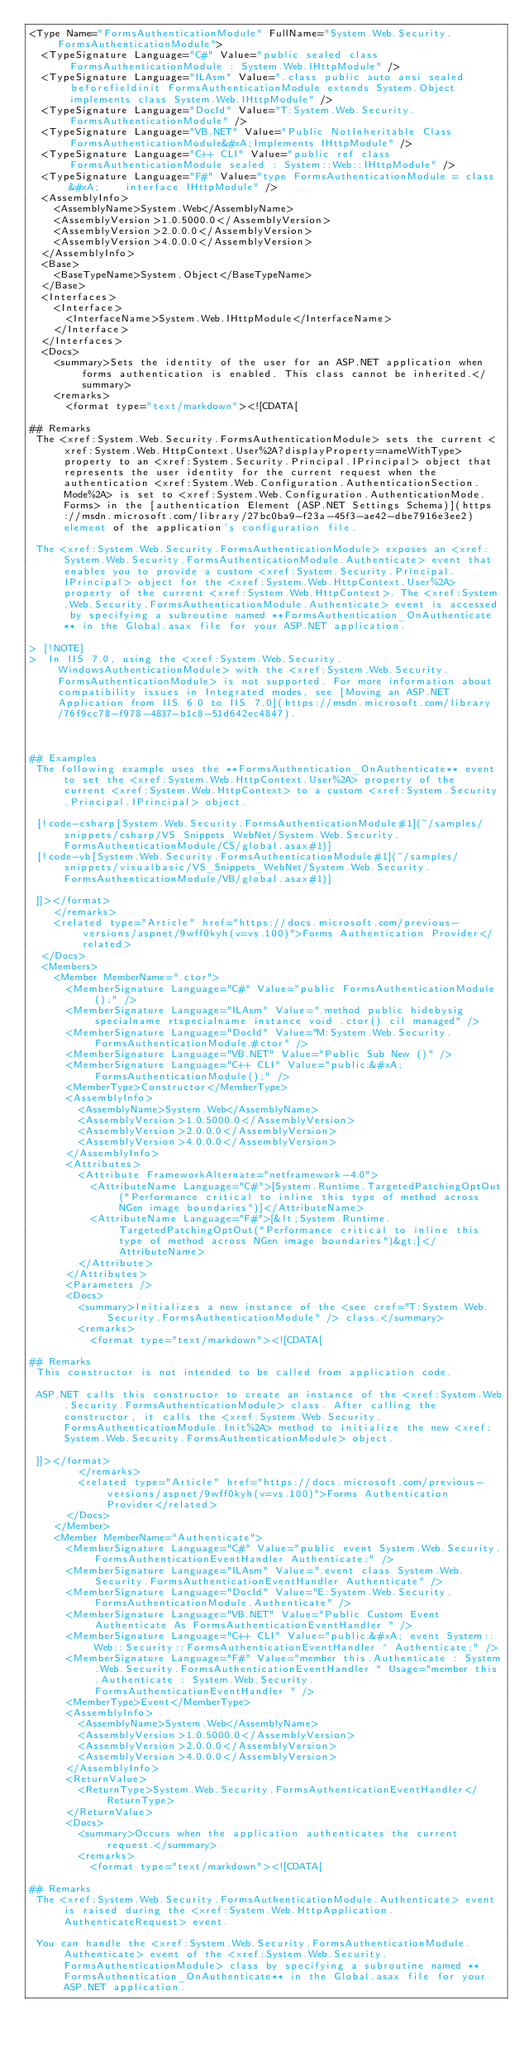<code> <loc_0><loc_0><loc_500><loc_500><_XML_><Type Name="FormsAuthenticationModule" FullName="System.Web.Security.FormsAuthenticationModule">
  <TypeSignature Language="C#" Value="public sealed class FormsAuthenticationModule : System.Web.IHttpModule" />
  <TypeSignature Language="ILAsm" Value=".class public auto ansi sealed beforefieldinit FormsAuthenticationModule extends System.Object implements class System.Web.IHttpModule" />
  <TypeSignature Language="DocId" Value="T:System.Web.Security.FormsAuthenticationModule" />
  <TypeSignature Language="VB.NET" Value="Public NotInheritable Class FormsAuthenticationModule&#xA;Implements IHttpModule" />
  <TypeSignature Language="C++ CLI" Value="public ref class FormsAuthenticationModule sealed : System::Web::IHttpModule" />
  <TypeSignature Language="F#" Value="type FormsAuthenticationModule = class&#xA;    interface IHttpModule" />
  <AssemblyInfo>
    <AssemblyName>System.Web</AssemblyName>
    <AssemblyVersion>1.0.5000.0</AssemblyVersion>
    <AssemblyVersion>2.0.0.0</AssemblyVersion>
    <AssemblyVersion>4.0.0.0</AssemblyVersion>
  </AssemblyInfo>
  <Base>
    <BaseTypeName>System.Object</BaseTypeName>
  </Base>
  <Interfaces>
    <Interface>
      <InterfaceName>System.Web.IHttpModule</InterfaceName>
    </Interface>
  </Interfaces>
  <Docs>
    <summary>Sets the identity of the user for an ASP.NET application when forms authentication is enabled. This class cannot be inherited.</summary>
    <remarks>
      <format type="text/markdown"><![CDATA[  
  
## Remarks  
 The <xref:System.Web.Security.FormsAuthenticationModule> sets the current <xref:System.Web.HttpContext.User%2A?displayProperty=nameWithType> property to an <xref:System.Security.Principal.IPrincipal> object that represents the user identity for the current request when the authentication <xref:System.Web.Configuration.AuthenticationSection.Mode%2A> is set to <xref:System.Web.Configuration.AuthenticationMode.Forms> in the [authentication Element (ASP.NET Settings Schema)](https://msdn.microsoft.com/library/27bc0ba9-f23a-45f3-ae42-dbe7916e3ee2) element of the application's configuration file.  
  
 The <xref:System.Web.Security.FormsAuthenticationModule> exposes an <xref:System.Web.Security.FormsAuthenticationModule.Authenticate> event that enables you to provide a custom <xref:System.Security.Principal.IPrincipal> object for the <xref:System.Web.HttpContext.User%2A> property of the current <xref:System.Web.HttpContext>. The <xref:System.Web.Security.FormsAuthenticationModule.Authenticate> event is accessed by specifying a subroutine named **FormsAuthentication_OnAuthenticate** in the Global.asax file for your ASP.NET application.  
  
> [!NOTE]
>  In IIS 7.0, using the <xref:System.Web.Security.WindowsAuthenticationModule> with the <xref:System.Web.Security.FormsAuthenticationModule> is not supported. For more information about compatibility issues in Integrated modes, see [Moving an ASP.NET Application from IIS 6.0 to IIS 7.0](https://msdn.microsoft.com/library/76f9cc78-f978-4837-b1c8-51d642ec4847).  
  
   
  
## Examples  
 The following example uses the **FormsAuthentication_OnAuthenticate** event to set the <xref:System.Web.HttpContext.User%2A> property of the current <xref:System.Web.HttpContext> to a custom <xref:System.Security.Principal.IPrincipal> object.  
  
 [!code-csharp[System.Web.Security.FormsAuthenticationModule#1](~/samples/snippets/csharp/VS_Snippets_WebNet/System.Web.Security.FormsAuthenticationModule/CS/global.asax#1)]
 [!code-vb[System.Web.Security.FormsAuthenticationModule#1](~/samples/snippets/visualbasic/VS_Snippets_WebNet/System.Web.Security.FormsAuthenticationModule/VB/global.asax#1)]  
  
 ]]></format>
    </remarks>
    <related type="Article" href="https://docs.microsoft.com/previous-versions/aspnet/9wff0kyh(v=vs.100)">Forms Authentication Provider</related>
  </Docs>
  <Members>
    <Member MemberName=".ctor">
      <MemberSignature Language="C#" Value="public FormsAuthenticationModule ();" />
      <MemberSignature Language="ILAsm" Value=".method public hidebysig specialname rtspecialname instance void .ctor() cil managed" />
      <MemberSignature Language="DocId" Value="M:System.Web.Security.FormsAuthenticationModule.#ctor" />
      <MemberSignature Language="VB.NET" Value="Public Sub New ()" />
      <MemberSignature Language="C++ CLI" Value="public:&#xA; FormsAuthenticationModule();" />
      <MemberType>Constructor</MemberType>
      <AssemblyInfo>
        <AssemblyName>System.Web</AssemblyName>
        <AssemblyVersion>1.0.5000.0</AssemblyVersion>
        <AssemblyVersion>2.0.0.0</AssemblyVersion>
        <AssemblyVersion>4.0.0.0</AssemblyVersion>
      </AssemblyInfo>
      <Attributes>
        <Attribute FrameworkAlternate="netframework-4.0">
          <AttributeName Language="C#">[System.Runtime.TargetedPatchingOptOut("Performance critical to inline this type of method across NGen image boundaries")]</AttributeName>
          <AttributeName Language="F#">[&lt;System.Runtime.TargetedPatchingOptOut("Performance critical to inline this type of method across NGen image boundaries")&gt;]</AttributeName>
        </Attribute>
      </Attributes>
      <Parameters />
      <Docs>
        <summary>Initializes a new instance of the <see cref="T:System.Web.Security.FormsAuthenticationModule" /> class.</summary>
        <remarks>
          <format type="text/markdown"><![CDATA[  
  
## Remarks  
 This constructor is not intended to be called from application code.  
  
 ASP.NET calls this constructor to create an instance of the <xref:System.Web.Security.FormsAuthenticationModule> class. After calling the constructor, it calls the <xref:System.Web.Security.FormsAuthenticationModule.Init%2A> method to initialize the new <xref:System.Web.Security.FormsAuthenticationModule> object.  
  
 ]]></format>
        </remarks>
        <related type="Article" href="https://docs.microsoft.com/previous-versions/aspnet/9wff0kyh(v=vs.100)">Forms Authentication Provider</related>
      </Docs>
    </Member>
    <Member MemberName="Authenticate">
      <MemberSignature Language="C#" Value="public event System.Web.Security.FormsAuthenticationEventHandler Authenticate;" />
      <MemberSignature Language="ILAsm" Value=".event class System.Web.Security.FormsAuthenticationEventHandler Authenticate" />
      <MemberSignature Language="DocId" Value="E:System.Web.Security.FormsAuthenticationModule.Authenticate" />
      <MemberSignature Language="VB.NET" Value="Public Custom Event Authenticate As FormsAuthenticationEventHandler " />
      <MemberSignature Language="C++ CLI" Value="public:&#xA; event System::Web::Security::FormsAuthenticationEventHandler ^ Authenticate;" />
      <MemberSignature Language="F#" Value="member this.Authenticate : System.Web.Security.FormsAuthenticationEventHandler " Usage="member this.Authenticate : System.Web.Security.FormsAuthenticationEventHandler " />
      <MemberType>Event</MemberType>
      <AssemblyInfo>
        <AssemblyName>System.Web</AssemblyName>
        <AssemblyVersion>1.0.5000.0</AssemblyVersion>
        <AssemblyVersion>2.0.0.0</AssemblyVersion>
        <AssemblyVersion>4.0.0.0</AssemblyVersion>
      </AssemblyInfo>
      <ReturnValue>
        <ReturnType>System.Web.Security.FormsAuthenticationEventHandler</ReturnType>
      </ReturnValue>
      <Docs>
        <summary>Occurs when the application authenticates the current request.</summary>
        <remarks>
          <format type="text/markdown"><![CDATA[  
  
## Remarks  
 The <xref:System.Web.Security.FormsAuthenticationModule.Authenticate> event is raised during the <xref:System.Web.HttpApplication.AuthenticateRequest> event.  
  
 You can handle the <xref:System.Web.Security.FormsAuthenticationModule.Authenticate> event of the <xref:System.Web.Security.FormsAuthenticationModule> class by specifying a subroutine named **FormsAuthentication_OnAuthenticate** in the Global.asax file for your ASP.NET application.  
  </code> 